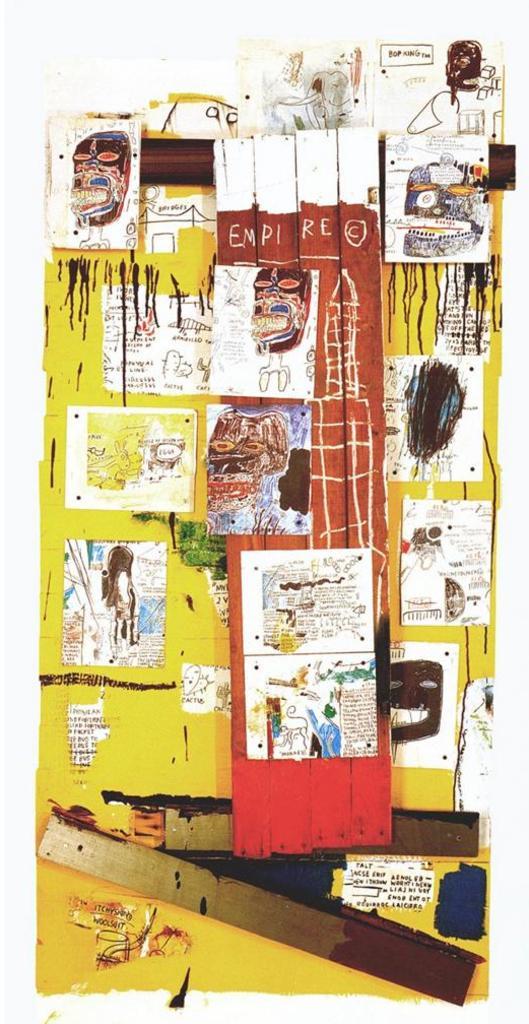How would you summarize this image in a sentence or two? In this image we can see the artwork which is in yellow color. Here we can see some images. 